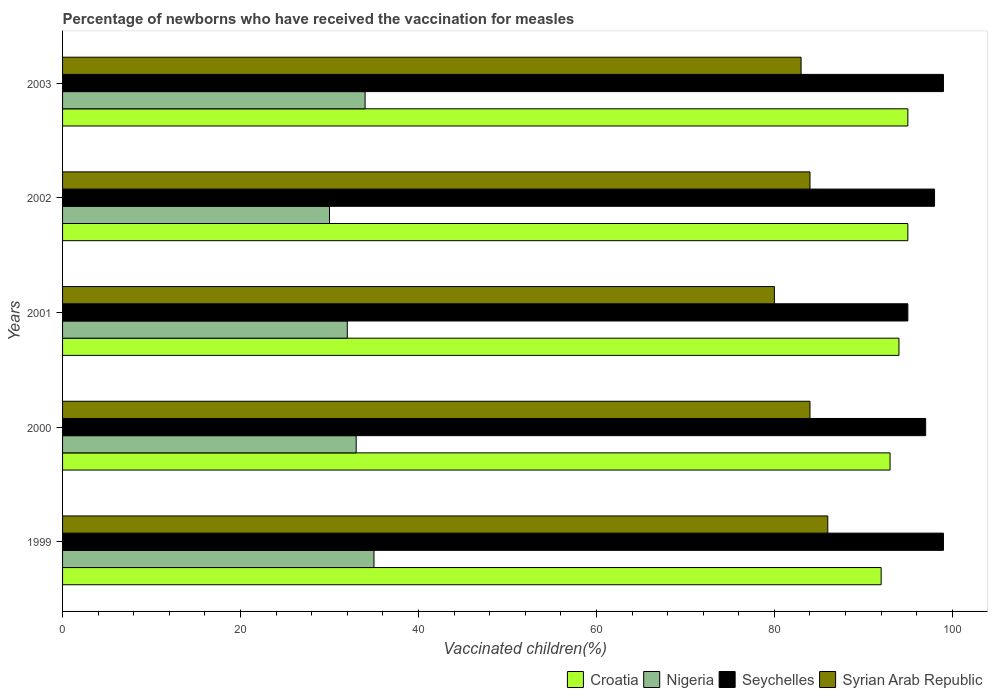How many groups of bars are there?
Your answer should be very brief. 5. Are the number of bars per tick equal to the number of legend labels?
Provide a succinct answer. Yes. What is the label of the 1st group of bars from the top?
Offer a terse response. 2003. In how many cases, is the number of bars for a given year not equal to the number of legend labels?
Offer a terse response. 0. What is the percentage of vaccinated children in Seychelles in 2000?
Your response must be concise. 97. Across all years, what is the minimum percentage of vaccinated children in Syrian Arab Republic?
Your answer should be compact. 80. In which year was the percentage of vaccinated children in Nigeria minimum?
Provide a short and direct response. 2002. What is the total percentage of vaccinated children in Croatia in the graph?
Your answer should be compact. 469. What is the difference between the percentage of vaccinated children in Nigeria in 1999 and that in 2000?
Keep it short and to the point. 2. What is the difference between the percentage of vaccinated children in Croatia in 2001 and the percentage of vaccinated children in Syrian Arab Republic in 2002?
Offer a terse response. 10. What is the average percentage of vaccinated children in Syrian Arab Republic per year?
Your answer should be very brief. 83.4. In how many years, is the percentage of vaccinated children in Nigeria greater than 32 %?
Keep it short and to the point. 3. What is the ratio of the percentage of vaccinated children in Nigeria in 1999 to that in 2001?
Provide a short and direct response. 1.09. What is the difference between the highest and the lowest percentage of vaccinated children in Croatia?
Keep it short and to the point. 3. What does the 4th bar from the top in 1999 represents?
Give a very brief answer. Croatia. What does the 1st bar from the bottom in 1999 represents?
Ensure brevity in your answer.  Croatia. Is it the case that in every year, the sum of the percentage of vaccinated children in Syrian Arab Republic and percentage of vaccinated children in Seychelles is greater than the percentage of vaccinated children in Nigeria?
Provide a succinct answer. Yes. How many bars are there?
Offer a terse response. 20. Are all the bars in the graph horizontal?
Make the answer very short. Yes. How many years are there in the graph?
Provide a short and direct response. 5. Are the values on the major ticks of X-axis written in scientific E-notation?
Offer a terse response. No. Does the graph contain any zero values?
Your response must be concise. No. Does the graph contain grids?
Provide a succinct answer. No. How many legend labels are there?
Keep it short and to the point. 4. What is the title of the graph?
Your answer should be compact. Percentage of newborns who have received the vaccination for measles. What is the label or title of the X-axis?
Make the answer very short. Vaccinated children(%). What is the label or title of the Y-axis?
Your response must be concise. Years. What is the Vaccinated children(%) in Croatia in 1999?
Offer a very short reply. 92. What is the Vaccinated children(%) in Seychelles in 1999?
Give a very brief answer. 99. What is the Vaccinated children(%) in Syrian Arab Republic in 1999?
Provide a succinct answer. 86. What is the Vaccinated children(%) in Croatia in 2000?
Ensure brevity in your answer.  93. What is the Vaccinated children(%) of Seychelles in 2000?
Your answer should be very brief. 97. What is the Vaccinated children(%) in Syrian Arab Republic in 2000?
Provide a short and direct response. 84. What is the Vaccinated children(%) in Croatia in 2001?
Keep it short and to the point. 94. What is the Vaccinated children(%) of Seychelles in 2001?
Offer a very short reply. 95. What is the Vaccinated children(%) in Syrian Arab Republic in 2001?
Provide a short and direct response. 80. What is the Vaccinated children(%) in Croatia in 2002?
Keep it short and to the point. 95. What is the Vaccinated children(%) of Seychelles in 2002?
Your answer should be compact. 98. What is the Vaccinated children(%) in Syrian Arab Republic in 2002?
Give a very brief answer. 84. What is the Vaccinated children(%) of Nigeria in 2003?
Keep it short and to the point. 34. What is the Vaccinated children(%) in Syrian Arab Republic in 2003?
Your answer should be very brief. 83. Across all years, what is the maximum Vaccinated children(%) of Croatia?
Give a very brief answer. 95. Across all years, what is the minimum Vaccinated children(%) of Croatia?
Provide a short and direct response. 92. Across all years, what is the minimum Vaccinated children(%) of Seychelles?
Make the answer very short. 95. Across all years, what is the minimum Vaccinated children(%) of Syrian Arab Republic?
Your answer should be very brief. 80. What is the total Vaccinated children(%) in Croatia in the graph?
Provide a succinct answer. 469. What is the total Vaccinated children(%) in Nigeria in the graph?
Offer a terse response. 164. What is the total Vaccinated children(%) of Seychelles in the graph?
Offer a terse response. 488. What is the total Vaccinated children(%) in Syrian Arab Republic in the graph?
Your response must be concise. 417. What is the difference between the Vaccinated children(%) in Croatia in 1999 and that in 2000?
Make the answer very short. -1. What is the difference between the Vaccinated children(%) of Seychelles in 1999 and that in 2000?
Keep it short and to the point. 2. What is the difference between the Vaccinated children(%) in Croatia in 1999 and that in 2001?
Provide a succinct answer. -2. What is the difference between the Vaccinated children(%) in Nigeria in 1999 and that in 2001?
Ensure brevity in your answer.  3. What is the difference between the Vaccinated children(%) of Syrian Arab Republic in 1999 and that in 2001?
Your answer should be compact. 6. What is the difference between the Vaccinated children(%) of Croatia in 1999 and that in 2002?
Your answer should be compact. -3. What is the difference between the Vaccinated children(%) of Seychelles in 1999 and that in 2002?
Give a very brief answer. 1. What is the difference between the Vaccinated children(%) of Croatia in 2000 and that in 2001?
Make the answer very short. -1. What is the difference between the Vaccinated children(%) in Nigeria in 2000 and that in 2001?
Your response must be concise. 1. What is the difference between the Vaccinated children(%) of Croatia in 2000 and that in 2002?
Your answer should be compact. -2. What is the difference between the Vaccinated children(%) in Syrian Arab Republic in 2000 and that in 2002?
Offer a very short reply. 0. What is the difference between the Vaccinated children(%) of Nigeria in 2000 and that in 2003?
Keep it short and to the point. -1. What is the difference between the Vaccinated children(%) of Seychelles in 2000 and that in 2003?
Provide a short and direct response. -2. What is the difference between the Vaccinated children(%) in Syrian Arab Republic in 2000 and that in 2003?
Make the answer very short. 1. What is the difference between the Vaccinated children(%) of Nigeria in 2001 and that in 2002?
Provide a short and direct response. 2. What is the difference between the Vaccinated children(%) of Syrian Arab Republic in 2001 and that in 2002?
Offer a very short reply. -4. What is the difference between the Vaccinated children(%) of Syrian Arab Republic in 2001 and that in 2003?
Offer a very short reply. -3. What is the difference between the Vaccinated children(%) of Croatia in 2002 and that in 2003?
Ensure brevity in your answer.  0. What is the difference between the Vaccinated children(%) of Seychelles in 2002 and that in 2003?
Offer a very short reply. -1. What is the difference between the Vaccinated children(%) of Syrian Arab Republic in 2002 and that in 2003?
Make the answer very short. 1. What is the difference between the Vaccinated children(%) in Croatia in 1999 and the Vaccinated children(%) in Nigeria in 2000?
Make the answer very short. 59. What is the difference between the Vaccinated children(%) of Croatia in 1999 and the Vaccinated children(%) of Seychelles in 2000?
Keep it short and to the point. -5. What is the difference between the Vaccinated children(%) in Croatia in 1999 and the Vaccinated children(%) in Syrian Arab Republic in 2000?
Offer a terse response. 8. What is the difference between the Vaccinated children(%) in Nigeria in 1999 and the Vaccinated children(%) in Seychelles in 2000?
Offer a very short reply. -62. What is the difference between the Vaccinated children(%) of Nigeria in 1999 and the Vaccinated children(%) of Syrian Arab Republic in 2000?
Keep it short and to the point. -49. What is the difference between the Vaccinated children(%) in Seychelles in 1999 and the Vaccinated children(%) in Syrian Arab Republic in 2000?
Ensure brevity in your answer.  15. What is the difference between the Vaccinated children(%) of Croatia in 1999 and the Vaccinated children(%) of Seychelles in 2001?
Keep it short and to the point. -3. What is the difference between the Vaccinated children(%) of Croatia in 1999 and the Vaccinated children(%) of Syrian Arab Republic in 2001?
Ensure brevity in your answer.  12. What is the difference between the Vaccinated children(%) in Nigeria in 1999 and the Vaccinated children(%) in Seychelles in 2001?
Ensure brevity in your answer.  -60. What is the difference between the Vaccinated children(%) in Nigeria in 1999 and the Vaccinated children(%) in Syrian Arab Republic in 2001?
Your response must be concise. -45. What is the difference between the Vaccinated children(%) in Croatia in 1999 and the Vaccinated children(%) in Nigeria in 2002?
Your response must be concise. 62. What is the difference between the Vaccinated children(%) in Croatia in 1999 and the Vaccinated children(%) in Syrian Arab Republic in 2002?
Your answer should be compact. 8. What is the difference between the Vaccinated children(%) in Nigeria in 1999 and the Vaccinated children(%) in Seychelles in 2002?
Give a very brief answer. -63. What is the difference between the Vaccinated children(%) in Nigeria in 1999 and the Vaccinated children(%) in Syrian Arab Republic in 2002?
Keep it short and to the point. -49. What is the difference between the Vaccinated children(%) of Croatia in 1999 and the Vaccinated children(%) of Nigeria in 2003?
Provide a succinct answer. 58. What is the difference between the Vaccinated children(%) of Croatia in 1999 and the Vaccinated children(%) of Seychelles in 2003?
Keep it short and to the point. -7. What is the difference between the Vaccinated children(%) of Croatia in 1999 and the Vaccinated children(%) of Syrian Arab Republic in 2003?
Provide a succinct answer. 9. What is the difference between the Vaccinated children(%) in Nigeria in 1999 and the Vaccinated children(%) in Seychelles in 2003?
Offer a terse response. -64. What is the difference between the Vaccinated children(%) in Nigeria in 1999 and the Vaccinated children(%) in Syrian Arab Republic in 2003?
Your answer should be compact. -48. What is the difference between the Vaccinated children(%) in Seychelles in 1999 and the Vaccinated children(%) in Syrian Arab Republic in 2003?
Offer a terse response. 16. What is the difference between the Vaccinated children(%) of Croatia in 2000 and the Vaccinated children(%) of Nigeria in 2001?
Provide a succinct answer. 61. What is the difference between the Vaccinated children(%) in Nigeria in 2000 and the Vaccinated children(%) in Seychelles in 2001?
Provide a short and direct response. -62. What is the difference between the Vaccinated children(%) in Nigeria in 2000 and the Vaccinated children(%) in Syrian Arab Republic in 2001?
Your response must be concise. -47. What is the difference between the Vaccinated children(%) in Seychelles in 2000 and the Vaccinated children(%) in Syrian Arab Republic in 2001?
Your answer should be compact. 17. What is the difference between the Vaccinated children(%) of Croatia in 2000 and the Vaccinated children(%) of Nigeria in 2002?
Your answer should be very brief. 63. What is the difference between the Vaccinated children(%) in Croatia in 2000 and the Vaccinated children(%) in Seychelles in 2002?
Your response must be concise. -5. What is the difference between the Vaccinated children(%) in Nigeria in 2000 and the Vaccinated children(%) in Seychelles in 2002?
Provide a short and direct response. -65. What is the difference between the Vaccinated children(%) in Nigeria in 2000 and the Vaccinated children(%) in Syrian Arab Republic in 2002?
Offer a terse response. -51. What is the difference between the Vaccinated children(%) in Seychelles in 2000 and the Vaccinated children(%) in Syrian Arab Republic in 2002?
Your response must be concise. 13. What is the difference between the Vaccinated children(%) in Croatia in 2000 and the Vaccinated children(%) in Nigeria in 2003?
Ensure brevity in your answer.  59. What is the difference between the Vaccinated children(%) in Croatia in 2000 and the Vaccinated children(%) in Seychelles in 2003?
Ensure brevity in your answer.  -6. What is the difference between the Vaccinated children(%) of Nigeria in 2000 and the Vaccinated children(%) of Seychelles in 2003?
Make the answer very short. -66. What is the difference between the Vaccinated children(%) in Nigeria in 2000 and the Vaccinated children(%) in Syrian Arab Republic in 2003?
Keep it short and to the point. -50. What is the difference between the Vaccinated children(%) of Croatia in 2001 and the Vaccinated children(%) of Nigeria in 2002?
Your answer should be very brief. 64. What is the difference between the Vaccinated children(%) of Croatia in 2001 and the Vaccinated children(%) of Syrian Arab Republic in 2002?
Your answer should be compact. 10. What is the difference between the Vaccinated children(%) of Nigeria in 2001 and the Vaccinated children(%) of Seychelles in 2002?
Give a very brief answer. -66. What is the difference between the Vaccinated children(%) in Nigeria in 2001 and the Vaccinated children(%) in Syrian Arab Republic in 2002?
Your answer should be compact. -52. What is the difference between the Vaccinated children(%) of Seychelles in 2001 and the Vaccinated children(%) of Syrian Arab Republic in 2002?
Keep it short and to the point. 11. What is the difference between the Vaccinated children(%) of Croatia in 2001 and the Vaccinated children(%) of Seychelles in 2003?
Your response must be concise. -5. What is the difference between the Vaccinated children(%) in Nigeria in 2001 and the Vaccinated children(%) in Seychelles in 2003?
Provide a succinct answer. -67. What is the difference between the Vaccinated children(%) in Nigeria in 2001 and the Vaccinated children(%) in Syrian Arab Republic in 2003?
Offer a terse response. -51. What is the difference between the Vaccinated children(%) in Seychelles in 2001 and the Vaccinated children(%) in Syrian Arab Republic in 2003?
Offer a very short reply. 12. What is the difference between the Vaccinated children(%) of Croatia in 2002 and the Vaccinated children(%) of Seychelles in 2003?
Give a very brief answer. -4. What is the difference between the Vaccinated children(%) in Croatia in 2002 and the Vaccinated children(%) in Syrian Arab Republic in 2003?
Ensure brevity in your answer.  12. What is the difference between the Vaccinated children(%) in Nigeria in 2002 and the Vaccinated children(%) in Seychelles in 2003?
Keep it short and to the point. -69. What is the difference between the Vaccinated children(%) of Nigeria in 2002 and the Vaccinated children(%) of Syrian Arab Republic in 2003?
Provide a short and direct response. -53. What is the average Vaccinated children(%) of Croatia per year?
Your response must be concise. 93.8. What is the average Vaccinated children(%) of Nigeria per year?
Keep it short and to the point. 32.8. What is the average Vaccinated children(%) of Seychelles per year?
Keep it short and to the point. 97.6. What is the average Vaccinated children(%) in Syrian Arab Republic per year?
Offer a terse response. 83.4. In the year 1999, what is the difference between the Vaccinated children(%) of Croatia and Vaccinated children(%) of Seychelles?
Keep it short and to the point. -7. In the year 1999, what is the difference between the Vaccinated children(%) of Croatia and Vaccinated children(%) of Syrian Arab Republic?
Ensure brevity in your answer.  6. In the year 1999, what is the difference between the Vaccinated children(%) of Nigeria and Vaccinated children(%) of Seychelles?
Your answer should be compact. -64. In the year 1999, what is the difference between the Vaccinated children(%) of Nigeria and Vaccinated children(%) of Syrian Arab Republic?
Make the answer very short. -51. In the year 2000, what is the difference between the Vaccinated children(%) of Croatia and Vaccinated children(%) of Nigeria?
Offer a very short reply. 60. In the year 2000, what is the difference between the Vaccinated children(%) of Croatia and Vaccinated children(%) of Syrian Arab Republic?
Keep it short and to the point. 9. In the year 2000, what is the difference between the Vaccinated children(%) of Nigeria and Vaccinated children(%) of Seychelles?
Provide a succinct answer. -64. In the year 2000, what is the difference between the Vaccinated children(%) of Nigeria and Vaccinated children(%) of Syrian Arab Republic?
Provide a short and direct response. -51. In the year 2001, what is the difference between the Vaccinated children(%) of Croatia and Vaccinated children(%) of Nigeria?
Offer a terse response. 62. In the year 2001, what is the difference between the Vaccinated children(%) in Croatia and Vaccinated children(%) in Seychelles?
Offer a very short reply. -1. In the year 2001, what is the difference between the Vaccinated children(%) in Croatia and Vaccinated children(%) in Syrian Arab Republic?
Offer a terse response. 14. In the year 2001, what is the difference between the Vaccinated children(%) in Nigeria and Vaccinated children(%) in Seychelles?
Your answer should be very brief. -63. In the year 2001, what is the difference between the Vaccinated children(%) in Nigeria and Vaccinated children(%) in Syrian Arab Republic?
Ensure brevity in your answer.  -48. In the year 2002, what is the difference between the Vaccinated children(%) of Croatia and Vaccinated children(%) of Seychelles?
Your response must be concise. -3. In the year 2002, what is the difference between the Vaccinated children(%) of Croatia and Vaccinated children(%) of Syrian Arab Republic?
Offer a terse response. 11. In the year 2002, what is the difference between the Vaccinated children(%) of Nigeria and Vaccinated children(%) of Seychelles?
Your answer should be very brief. -68. In the year 2002, what is the difference between the Vaccinated children(%) in Nigeria and Vaccinated children(%) in Syrian Arab Republic?
Your answer should be very brief. -54. In the year 2002, what is the difference between the Vaccinated children(%) of Seychelles and Vaccinated children(%) of Syrian Arab Republic?
Provide a succinct answer. 14. In the year 2003, what is the difference between the Vaccinated children(%) of Croatia and Vaccinated children(%) of Nigeria?
Provide a succinct answer. 61. In the year 2003, what is the difference between the Vaccinated children(%) of Nigeria and Vaccinated children(%) of Seychelles?
Provide a short and direct response. -65. In the year 2003, what is the difference between the Vaccinated children(%) of Nigeria and Vaccinated children(%) of Syrian Arab Republic?
Provide a succinct answer. -49. What is the ratio of the Vaccinated children(%) of Croatia in 1999 to that in 2000?
Your answer should be very brief. 0.99. What is the ratio of the Vaccinated children(%) in Nigeria in 1999 to that in 2000?
Your answer should be compact. 1.06. What is the ratio of the Vaccinated children(%) in Seychelles in 1999 to that in 2000?
Your answer should be very brief. 1.02. What is the ratio of the Vaccinated children(%) of Syrian Arab Republic in 1999 to that in 2000?
Offer a terse response. 1.02. What is the ratio of the Vaccinated children(%) in Croatia in 1999 to that in 2001?
Your answer should be very brief. 0.98. What is the ratio of the Vaccinated children(%) of Nigeria in 1999 to that in 2001?
Provide a short and direct response. 1.09. What is the ratio of the Vaccinated children(%) of Seychelles in 1999 to that in 2001?
Ensure brevity in your answer.  1.04. What is the ratio of the Vaccinated children(%) of Syrian Arab Republic in 1999 to that in 2001?
Offer a terse response. 1.07. What is the ratio of the Vaccinated children(%) of Croatia in 1999 to that in 2002?
Keep it short and to the point. 0.97. What is the ratio of the Vaccinated children(%) in Seychelles in 1999 to that in 2002?
Offer a very short reply. 1.01. What is the ratio of the Vaccinated children(%) of Syrian Arab Republic in 1999 to that in 2002?
Your answer should be very brief. 1.02. What is the ratio of the Vaccinated children(%) of Croatia in 1999 to that in 2003?
Provide a succinct answer. 0.97. What is the ratio of the Vaccinated children(%) in Nigeria in 1999 to that in 2003?
Make the answer very short. 1.03. What is the ratio of the Vaccinated children(%) in Syrian Arab Republic in 1999 to that in 2003?
Give a very brief answer. 1.04. What is the ratio of the Vaccinated children(%) in Croatia in 2000 to that in 2001?
Offer a terse response. 0.99. What is the ratio of the Vaccinated children(%) of Nigeria in 2000 to that in 2001?
Make the answer very short. 1.03. What is the ratio of the Vaccinated children(%) in Seychelles in 2000 to that in 2001?
Ensure brevity in your answer.  1.02. What is the ratio of the Vaccinated children(%) of Croatia in 2000 to that in 2002?
Provide a succinct answer. 0.98. What is the ratio of the Vaccinated children(%) of Seychelles in 2000 to that in 2002?
Ensure brevity in your answer.  0.99. What is the ratio of the Vaccinated children(%) in Syrian Arab Republic in 2000 to that in 2002?
Offer a terse response. 1. What is the ratio of the Vaccinated children(%) in Croatia in 2000 to that in 2003?
Offer a terse response. 0.98. What is the ratio of the Vaccinated children(%) in Nigeria in 2000 to that in 2003?
Provide a short and direct response. 0.97. What is the ratio of the Vaccinated children(%) in Seychelles in 2000 to that in 2003?
Your answer should be compact. 0.98. What is the ratio of the Vaccinated children(%) in Nigeria in 2001 to that in 2002?
Give a very brief answer. 1.07. What is the ratio of the Vaccinated children(%) of Seychelles in 2001 to that in 2002?
Provide a short and direct response. 0.97. What is the ratio of the Vaccinated children(%) in Seychelles in 2001 to that in 2003?
Provide a short and direct response. 0.96. What is the ratio of the Vaccinated children(%) of Syrian Arab Republic in 2001 to that in 2003?
Provide a short and direct response. 0.96. What is the ratio of the Vaccinated children(%) in Nigeria in 2002 to that in 2003?
Provide a short and direct response. 0.88. What is the ratio of the Vaccinated children(%) of Seychelles in 2002 to that in 2003?
Offer a very short reply. 0.99. What is the ratio of the Vaccinated children(%) in Syrian Arab Republic in 2002 to that in 2003?
Offer a terse response. 1.01. What is the difference between the highest and the second highest Vaccinated children(%) of Seychelles?
Your response must be concise. 0. What is the difference between the highest and the second highest Vaccinated children(%) of Syrian Arab Republic?
Your response must be concise. 2. What is the difference between the highest and the lowest Vaccinated children(%) of Croatia?
Give a very brief answer. 3. 